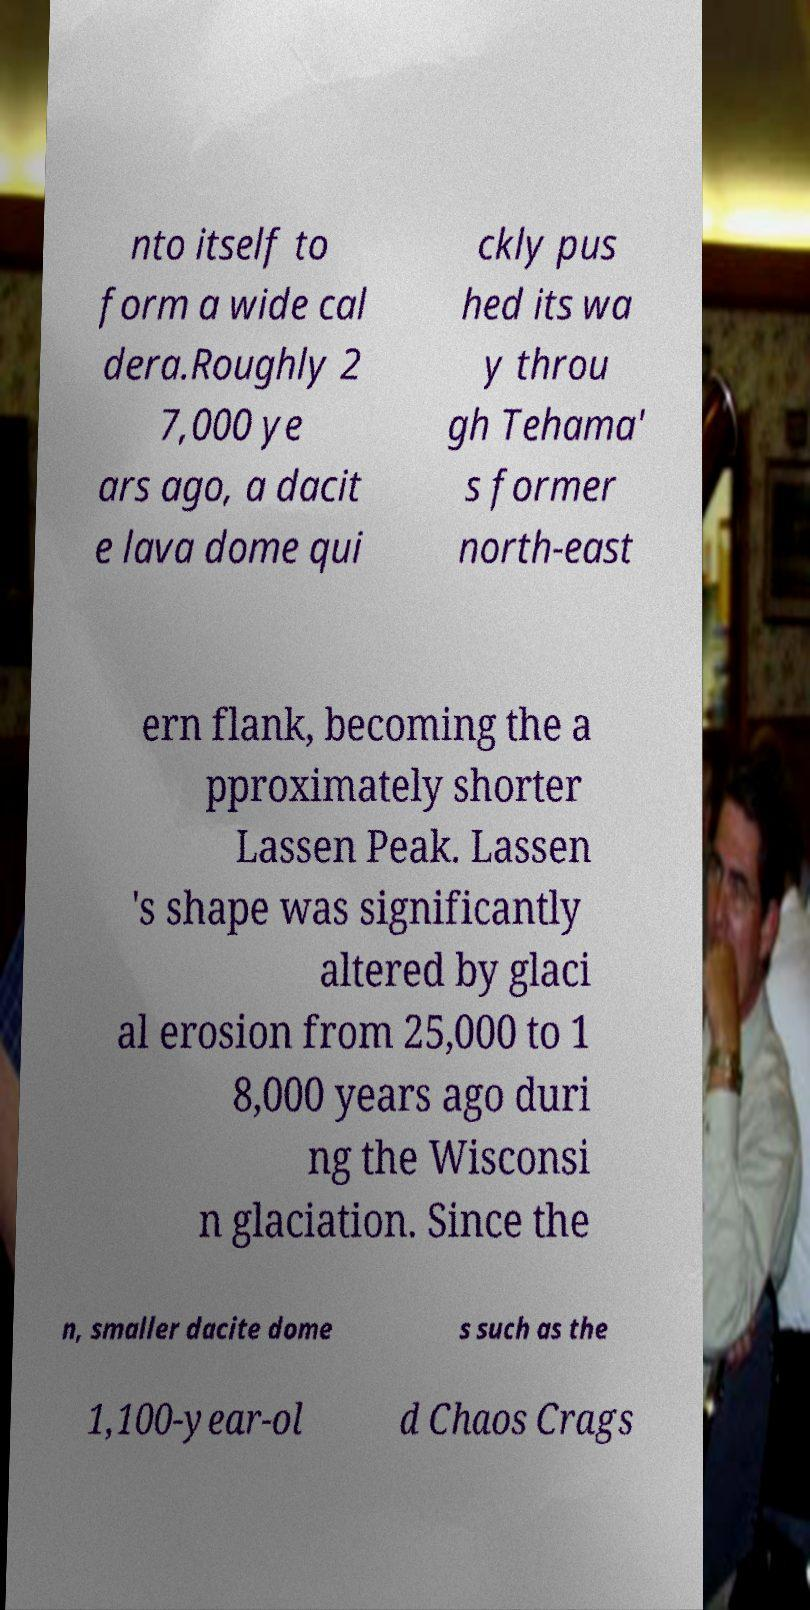There's text embedded in this image that I need extracted. Can you transcribe it verbatim? nto itself to form a wide cal dera.Roughly 2 7,000 ye ars ago, a dacit e lava dome qui ckly pus hed its wa y throu gh Tehama' s former north-east ern flank, becoming the a pproximately shorter Lassen Peak. Lassen 's shape was significantly altered by glaci al erosion from 25,000 to 1 8,000 years ago duri ng the Wisconsi n glaciation. Since the n, smaller dacite dome s such as the 1,100-year-ol d Chaos Crags 